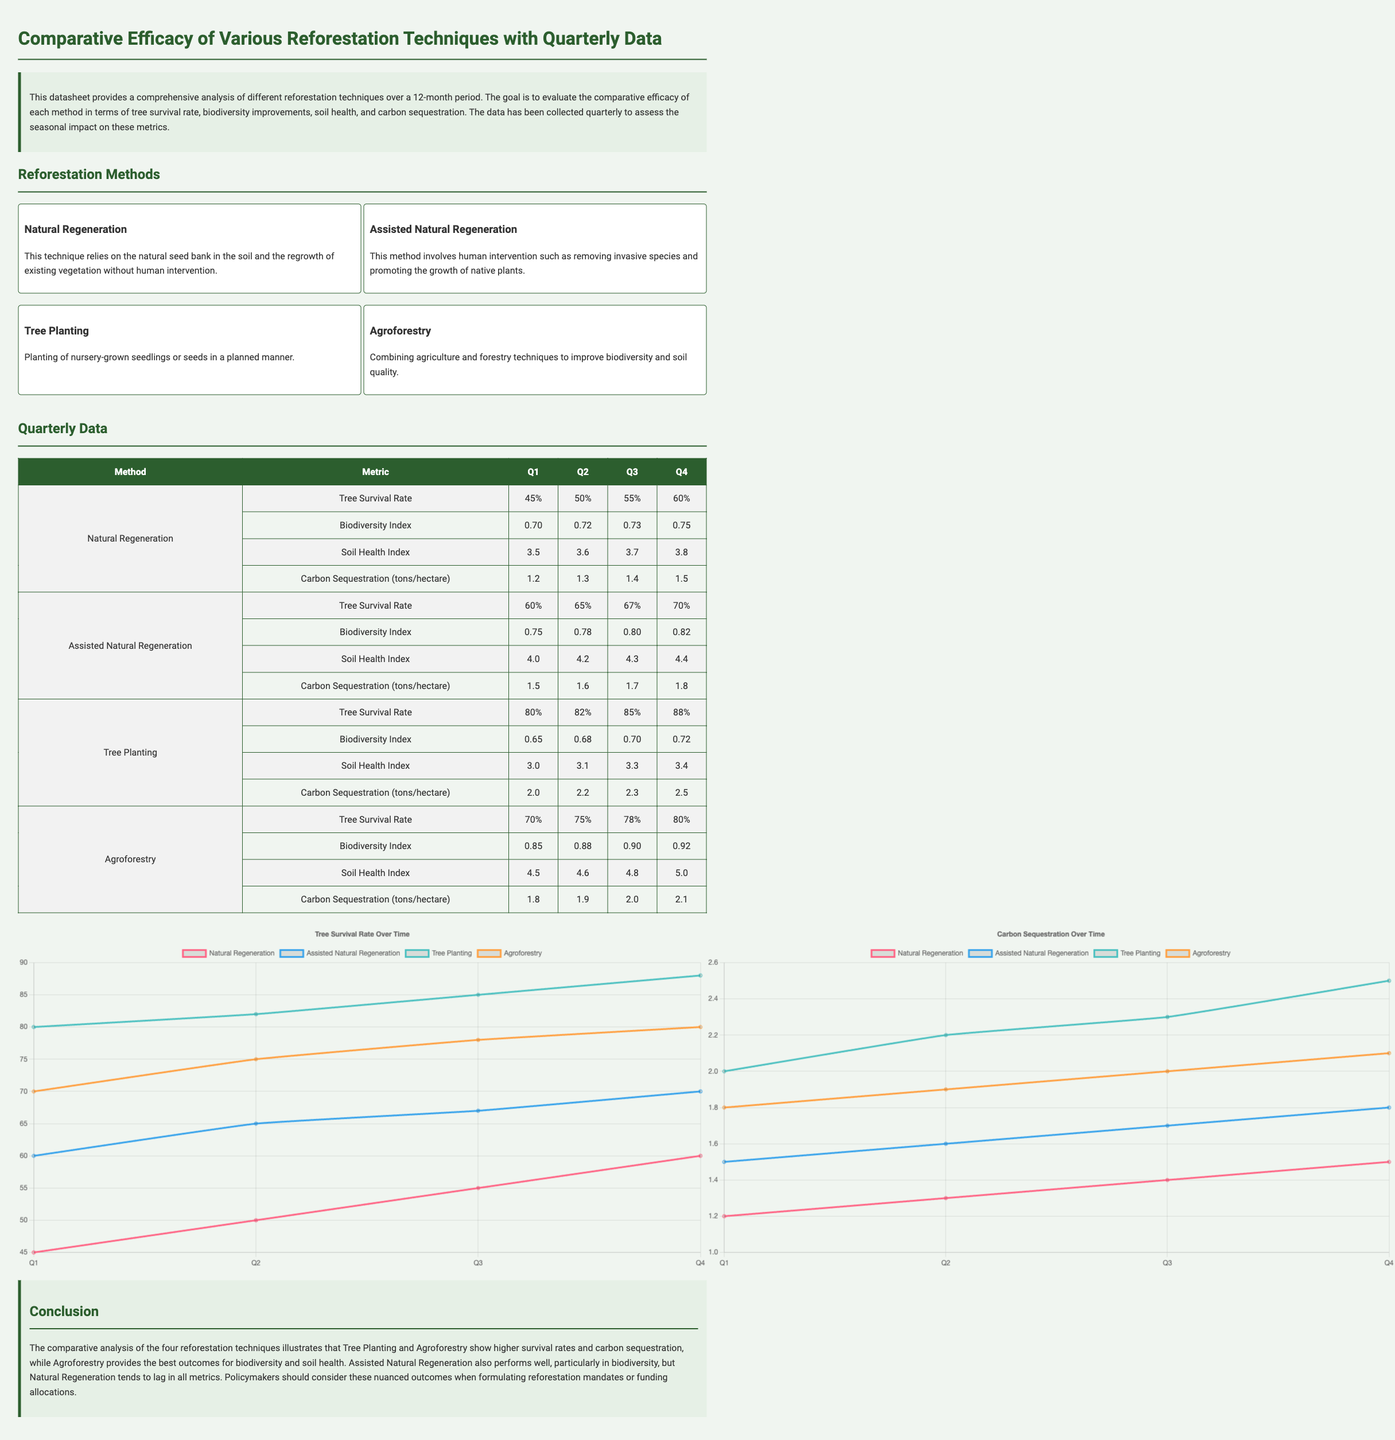What is the highest tree survival rate by Q4? The highest tree survival rate by Q4 is observed in Tree Planting, which reached 88%.
Answer: 88% Which reforestation technique had the lowest carbon sequestration in Q1? The lowest carbon sequestration in Q1 was associated with Natural Regeneration, which had 1.2 tons/hectare.
Answer: 1.2 tons/hectare What is the biodiversity index for Agroforestry in Q3? The biodiversity index for Agroforestry in Q3 is 0.90.
Answer: 0.90 Which method shows the greatest improvement in tree survival rate from Q1 to Q4? Tree Planting shows the greatest improvement, increasing from 80% in Q1 to 88% in Q4.
Answer: Tree Planting In which quarter did Assisted Natural Regeneration first exceed a tree survival rate of 65%? Assisted Natural Regeneration first exceeded a tree survival rate of 65% in Q2.
Answer: Q2 What is the soil health index for Assisted Natural Regeneration by Q4? The soil health index for Assisted Natural Regeneration by Q4 is 4.4.
Answer: 4.4 Which two methods have similar tree survival rates by Q4? Agroforestry and Assisted Natural Regeneration have similar tree survival rates (80% and 70%, respectively) by Q4.
Answer: Agroforestry and Assisted Natural Regeneration What is the document type of this report? This report is a datasheet comparing various reforestation techniques.
Answer: Datasheet 